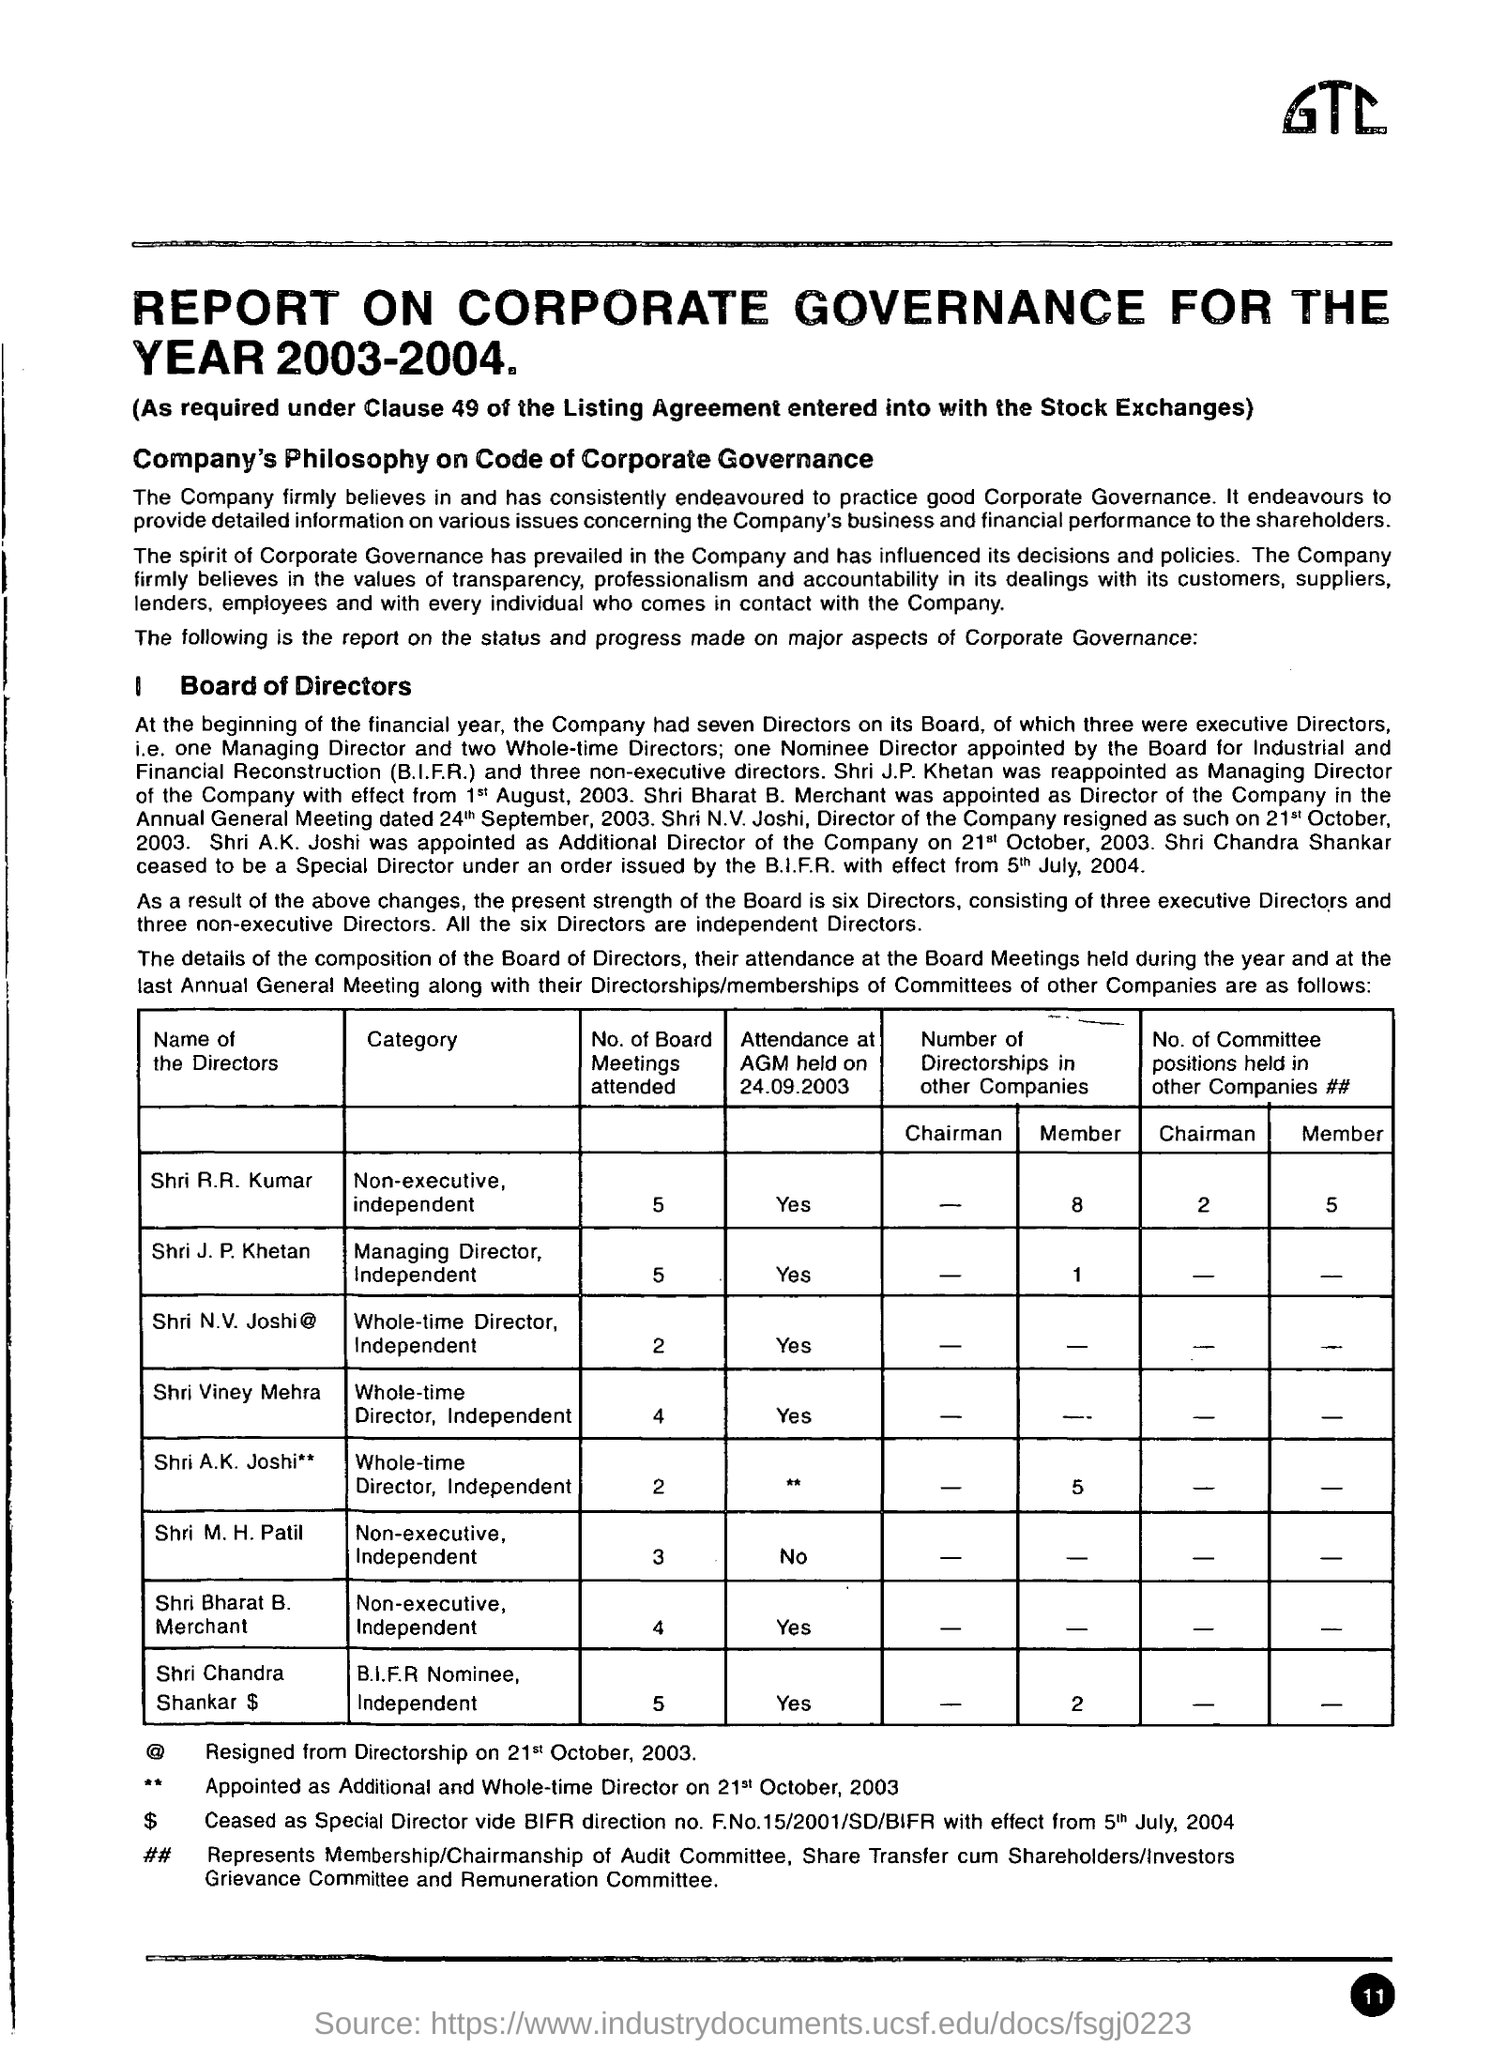Indicate a few pertinent items in this graphic. At the start of the financial year, the company had seven directors. Director Shri R.R Kumar has attended 5 meetings of the Board. 